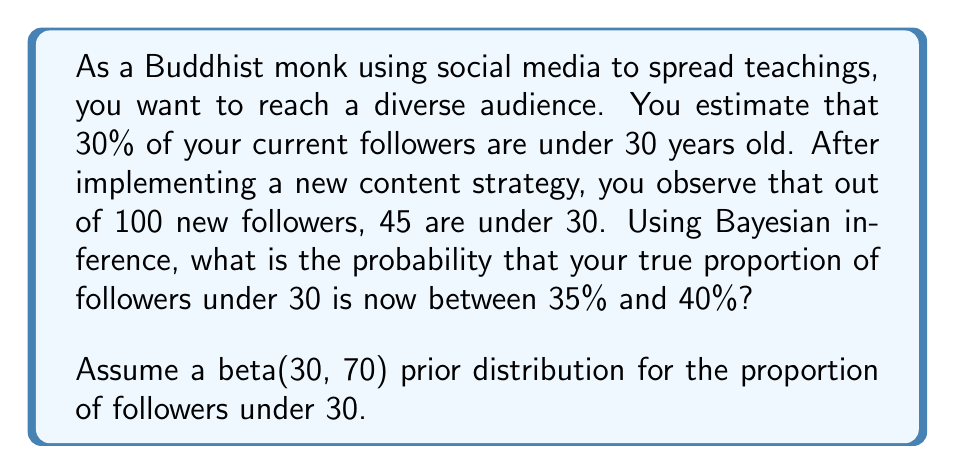Solve this math problem. Let's approach this step-by-step using Bayesian inference:

1) We start with a prior beta distribution: $\text{Beta}(30, 70)$

2) We observe 45 successes (followers under 30) out of 100 new followers

3) The posterior distribution is also a beta distribution:
   $\text{Beta}(30 + 45, 70 + 55) = \text{Beta}(75, 125)$

4) To find the probability that the true proportion is between 35% and 40%, we need to integrate the posterior distribution between these values:

   $$P(0.35 < \theta < 0.40) = \int_{0.35}^{0.40} \frac{\theta^{74}(1-\theta)^{124}}{B(75,125)} d\theta$$

   where $B(75,125)$ is the beta function

5) This integral doesn't have a closed-form solution, so we need to use numerical integration or the cumulative distribution function (CDF) of the beta distribution:

   $$P(0.35 < \theta < 0.40) = F_{\text{Beta}(75,125)}(0.40) - F_{\text{Beta}(75,125)}(0.35)$$

6) Using a statistical software or calculator:
   
   $F_{\text{Beta}(75,125)}(0.40) \approx 0.9730$
   $F_{\text{Beta}(75,125)}(0.35) \approx 0.3762$

7) Therefore:
   
   $$P(0.35 < \theta < 0.40) \approx 0.9730 - 0.3762 = 0.5968$$
Answer: $0.5968$ or approximately $59.68\%$ 